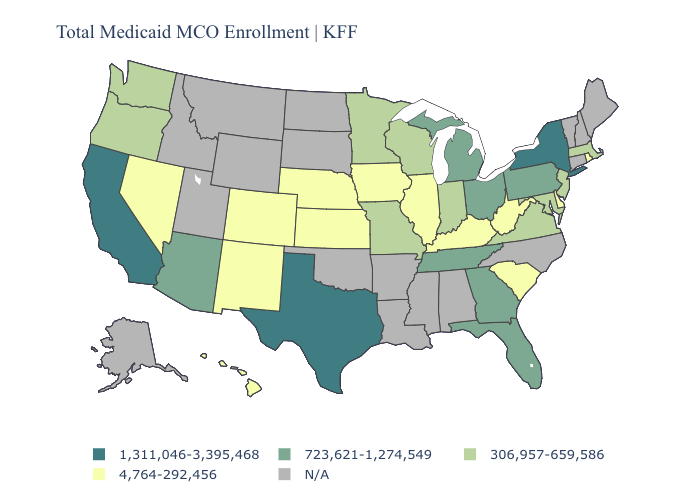What is the value of Wyoming?
Write a very short answer. N/A. What is the lowest value in states that border Vermont?
Keep it brief. 306,957-659,586. Name the states that have a value in the range N/A?
Answer briefly. Alabama, Alaska, Arkansas, Connecticut, Idaho, Louisiana, Maine, Mississippi, Montana, New Hampshire, North Carolina, North Dakota, Oklahoma, South Dakota, Utah, Vermont, Wyoming. What is the value of Michigan?
Keep it brief. 723,621-1,274,549. What is the value of Pennsylvania?
Short answer required. 723,621-1,274,549. Name the states that have a value in the range 306,957-659,586?
Quick response, please. Indiana, Maryland, Massachusetts, Minnesota, Missouri, New Jersey, Oregon, Virginia, Washington, Wisconsin. Name the states that have a value in the range 4,764-292,456?
Keep it brief. Colorado, Delaware, Hawaii, Illinois, Iowa, Kansas, Kentucky, Nebraska, Nevada, New Mexico, Rhode Island, South Carolina, West Virginia. How many symbols are there in the legend?
Write a very short answer. 5. Does Hawaii have the lowest value in the USA?
Short answer required. Yes. Which states have the highest value in the USA?
Keep it brief. California, New York, Texas. Does Washington have the lowest value in the USA?
Concise answer only. No. Name the states that have a value in the range N/A?
Keep it brief. Alabama, Alaska, Arkansas, Connecticut, Idaho, Louisiana, Maine, Mississippi, Montana, New Hampshire, North Carolina, North Dakota, Oklahoma, South Dakota, Utah, Vermont, Wyoming. 